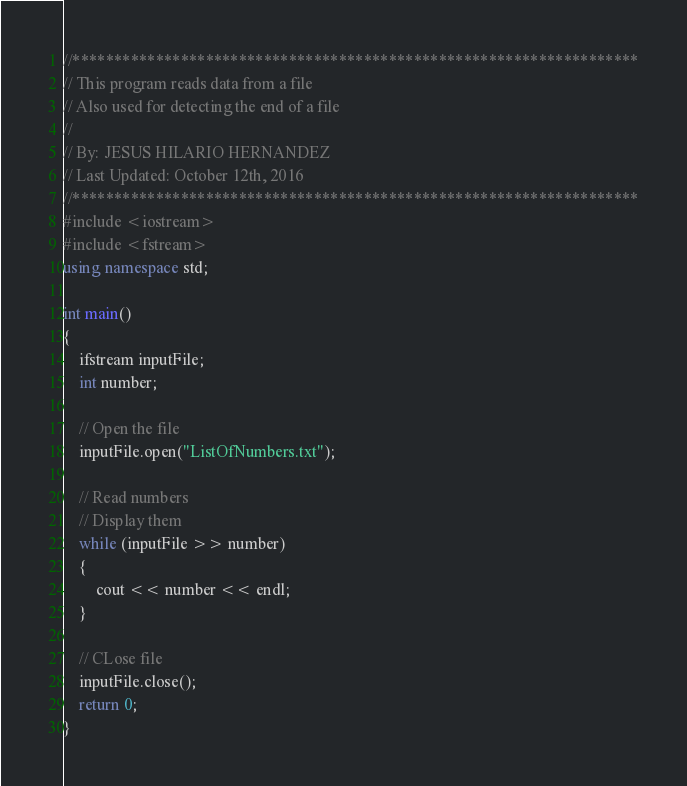<code> <loc_0><loc_0><loc_500><loc_500><_C++_>//********************************************************************
// This program reads data from a file
// Also used for detecting the end of a file
//
// By: JESUS HILARIO HERNANDEZ
// Last Updated: October 12th, 2016
//********************************************************************
#include <iostream>
#include <fstream>
using namespace std;

int main()
{
    ifstream inputFile;
    int number;

    // Open the file
    inputFile.open("ListOfNumbers.txt");

    // Read numbers
    // Display them
    while (inputFile >> number)
    {
        cout << number << endl;
    }

    // CLose file
    inputFile.close();
    return 0;
}
</code> 